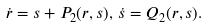Convert formula to latex. <formula><loc_0><loc_0><loc_500><loc_500>\dot { r } = s + P _ { 2 } ( r , s ) , \, \dot { s } = Q _ { 2 } ( r , s ) .</formula> 